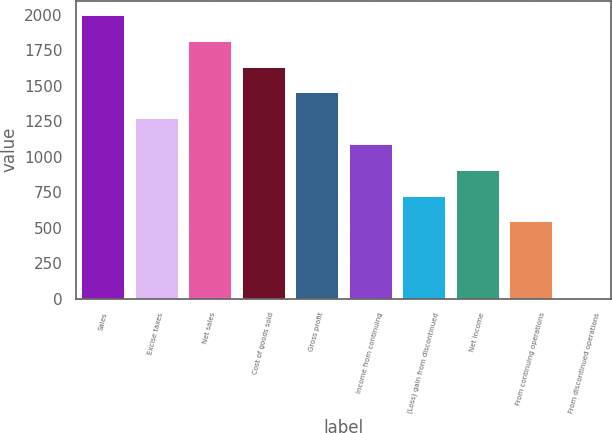<chart> <loc_0><loc_0><loc_500><loc_500><bar_chart><fcel>Sales<fcel>Excise taxes<fcel>Net sales<fcel>Cost of goods sold<fcel>Gross profit<fcel>Income from continuing<fcel>(Loss) gain from discontinued<fcel>Net income<fcel>From continuing operations<fcel>From discontinued operations<nl><fcel>1997.82<fcel>1271.36<fcel>1816.2<fcel>1634.59<fcel>1452.97<fcel>1089.74<fcel>726.5<fcel>908.12<fcel>544.89<fcel>0.05<nl></chart> 